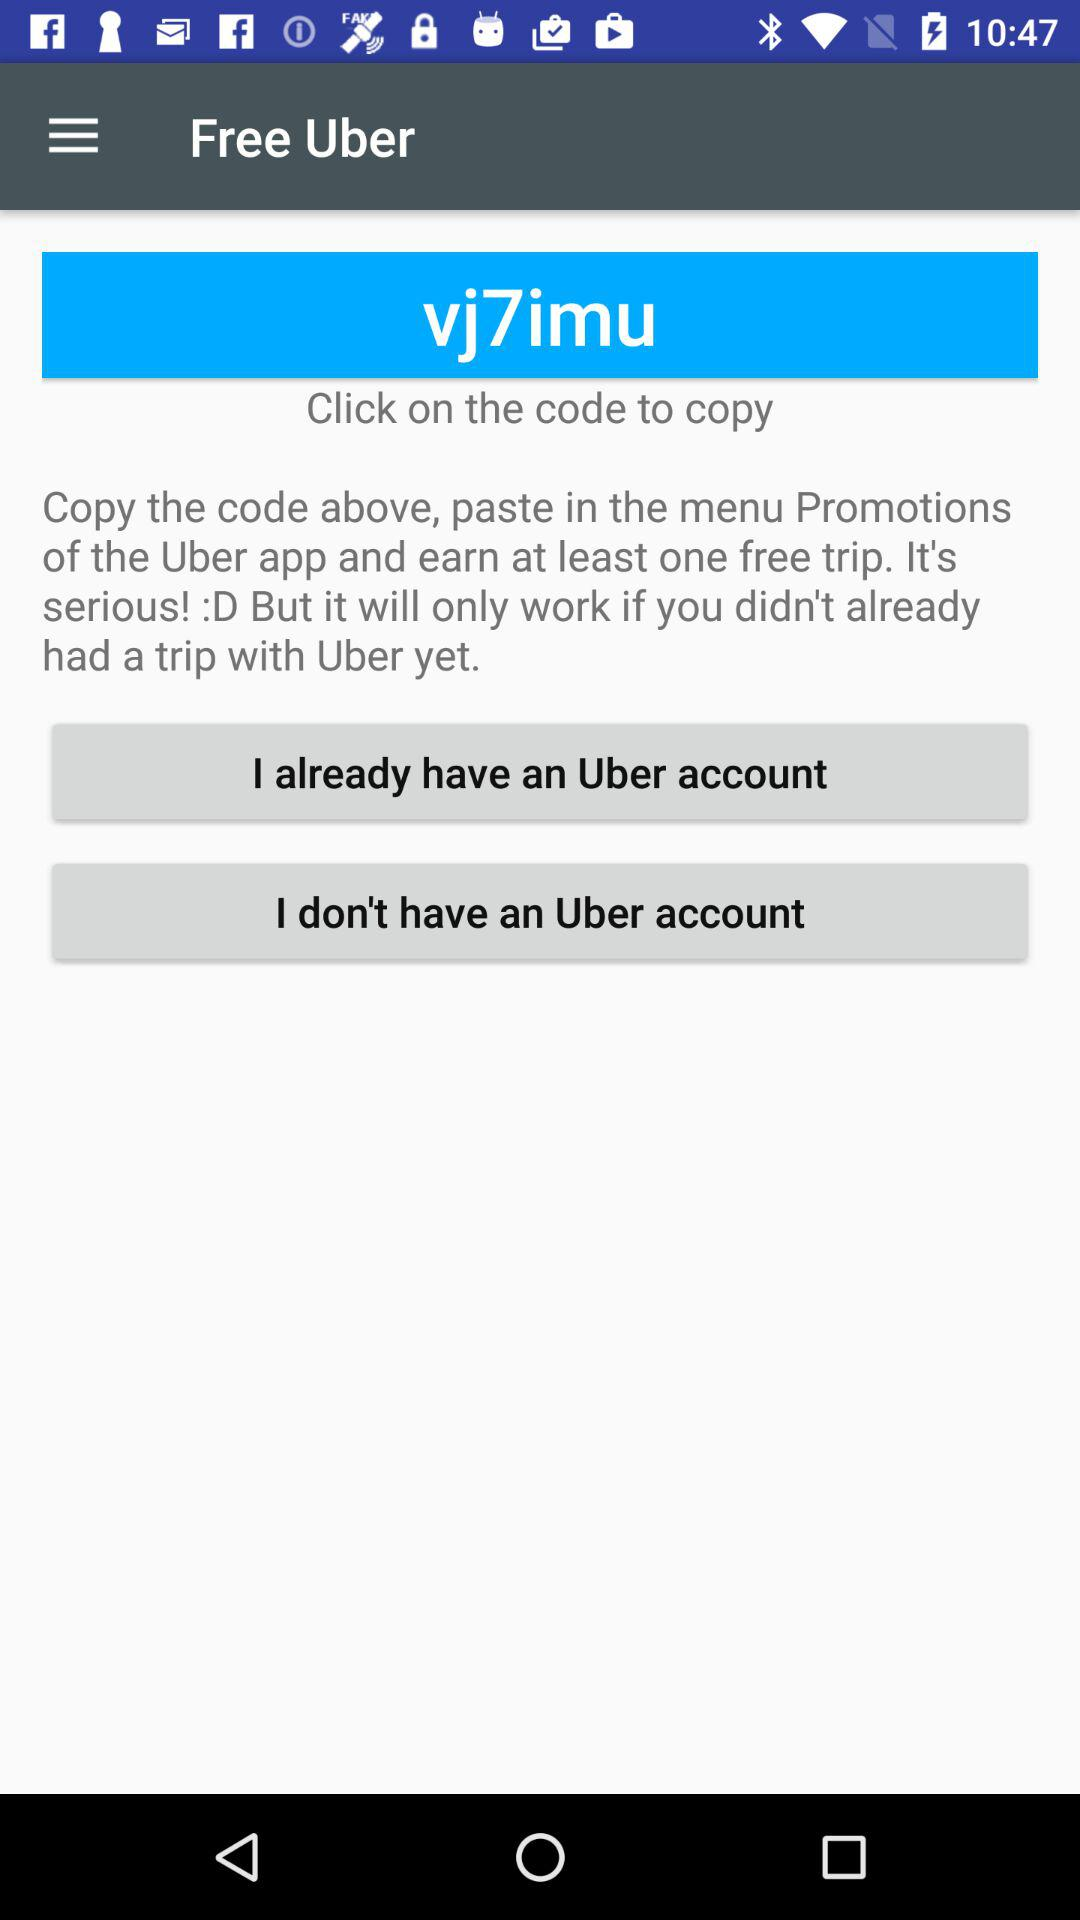How user can earn one free trip? You can earn one free trip "Copy the code above, paste in the menu Promotions of the Uber app ". 